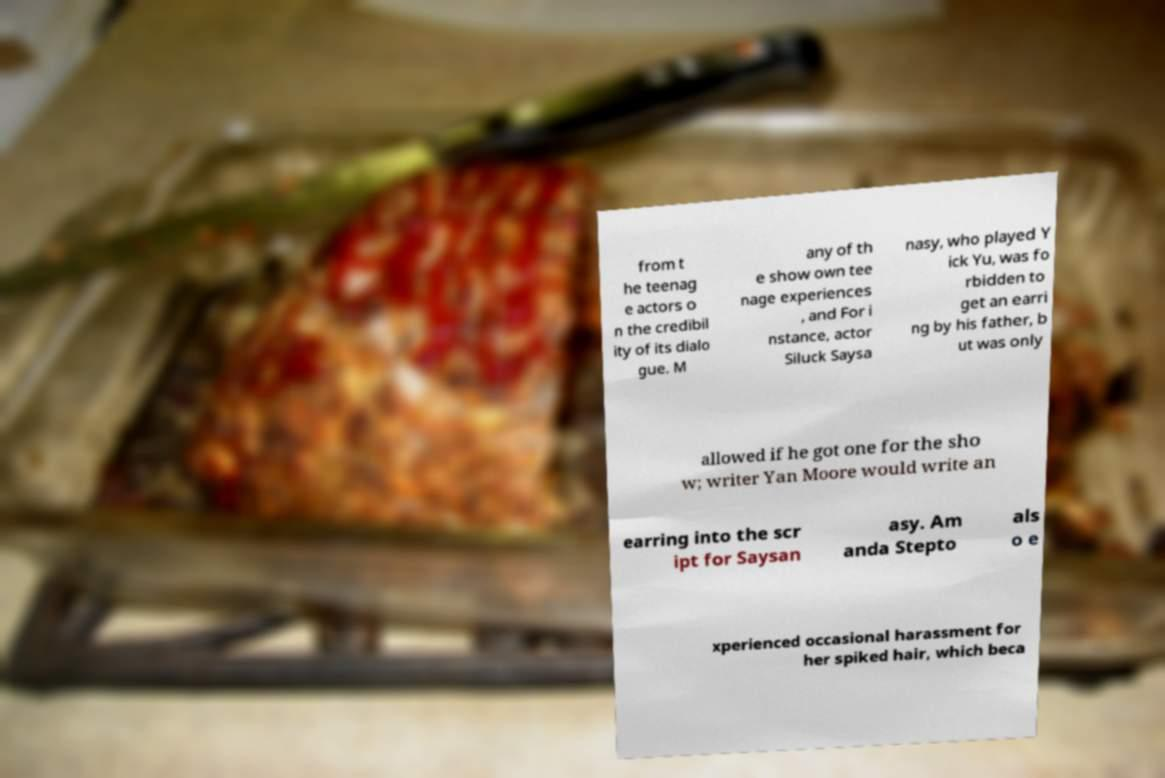Please identify and transcribe the text found in this image. from t he teenag e actors o n the credibil ity of its dialo gue. M any of th e show own tee nage experiences , and For i nstance, actor Siluck Saysa nasy, who played Y ick Yu, was fo rbidden to get an earri ng by his father, b ut was only allowed if he got one for the sho w; writer Yan Moore would write an earring into the scr ipt for Saysan asy. Am anda Stepto als o e xperienced occasional harassment for her spiked hair, which beca 